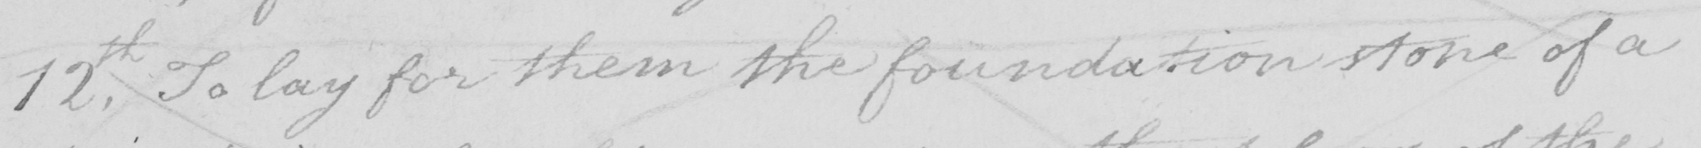Transcribe the text shown in this historical manuscript line. 12th . To lay for them the foundation stone of a 